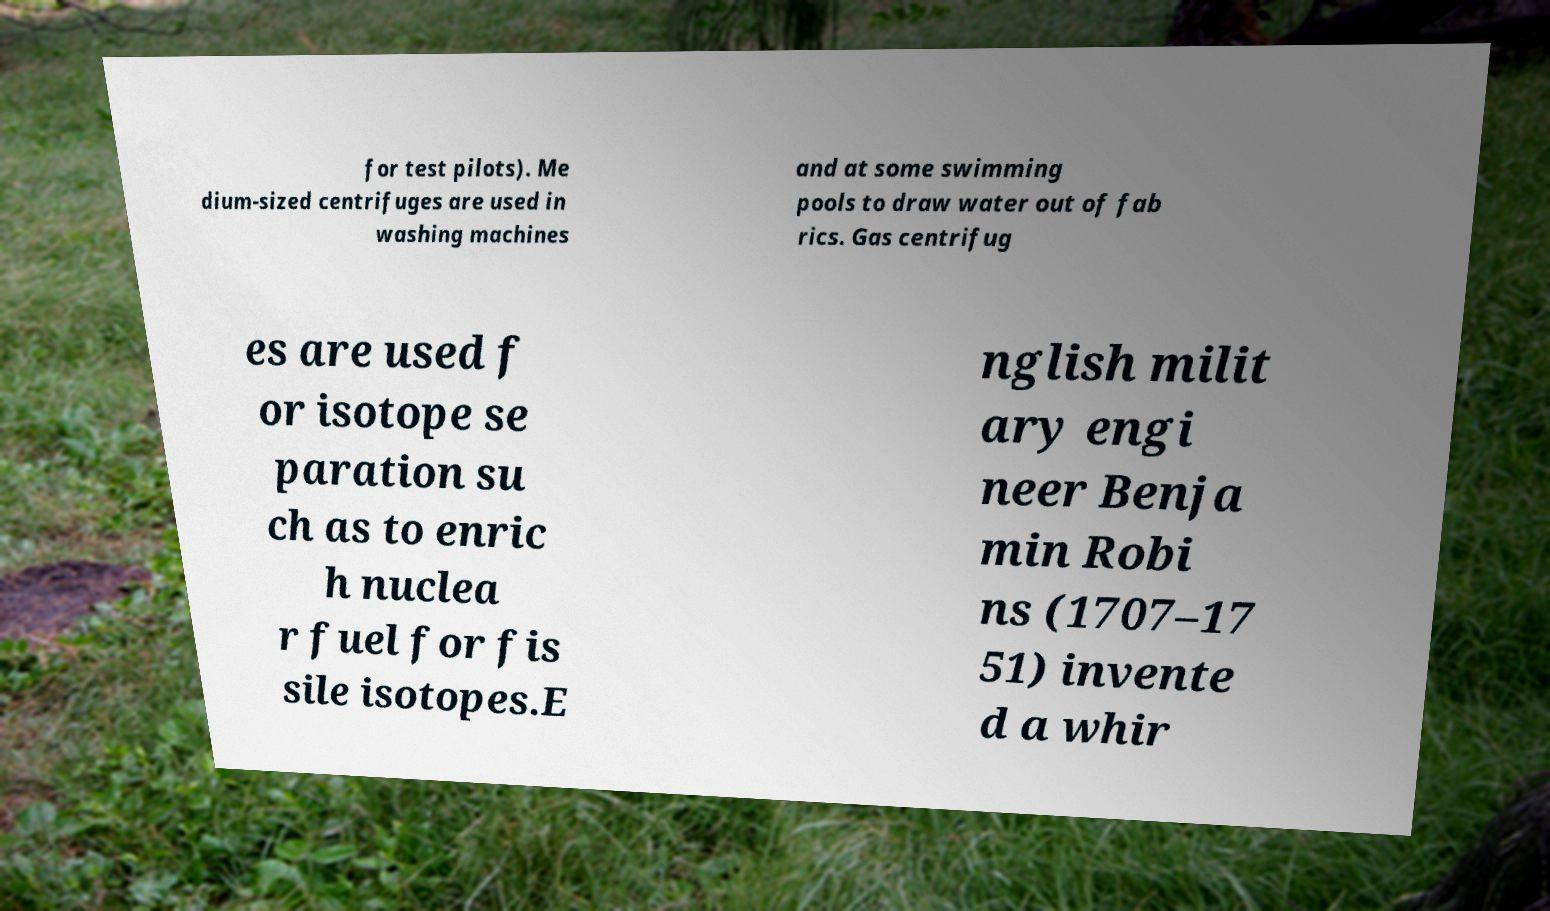Please read and relay the text visible in this image. What does it say? for test pilots). Me dium-sized centrifuges are used in washing machines and at some swimming pools to draw water out of fab rics. Gas centrifug es are used f or isotope se paration su ch as to enric h nuclea r fuel for fis sile isotopes.E nglish milit ary engi neer Benja min Robi ns (1707–17 51) invente d a whir 